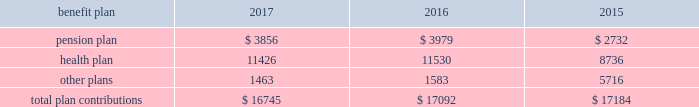112 / sl green realty corp .
2017 annual report 20 .
Commitments and contingencies legal proceedings as of december a031 , 2017 , the company and the operating partnership were not involved in any material litigation nor , to management 2019s knowledge , was any material litigation threat- ened against us or our portfolio which if adversely determined could have a material adverse impact on us .
Environmental matters our management believes that the properties are in compliance in all material respects with applicable federal , state and local ordinances and regulations regarding environmental issues .
Management is not aware of any environmental liability that it believes would have a materially adverse impact on our financial position , results of operations or cash flows .
Management is unaware of any instances in which it would incur significant envi- ronmental cost if any of our properties were sold .
Employment agreements we have entered into employment agreements with certain exec- utives , which expire between december a02018 and february a02020 .
The minimum cash-based compensation , including base sal- ary and guaranteed bonus payments , associated with these employment agreements total $ 5.4 a0million for 2018 .
In addition these employment agreements provide for deferred compen- sation awards based on our stock price and which were valued at $ 1.6 a0million on the grant date .
The value of these awards may change based on fluctuations in our stock price .
Insurance we maintain 201call-risk 201d property and rental value coverage ( includ- ing coverage regarding the perils of flood , earthquake and terrorism , excluding nuclear , biological , chemical , and radiological terrorism ( 201cnbcr 201d ) ) , within three property insurance programs and liability insurance .
Separate property and liability coverage may be purchased on a stand-alone basis for certain assets , such as the development of one vanderbilt .
Additionally , our captive insurance company , belmont insurance company , or belmont , pro- vides coverage for nbcr terrorist acts above a specified trigger , although if belmont is required to pay a claim under our insur- ance policies , we would ultimately record the loss to the extent of belmont 2019s required payment .
However , there is no assurance that in the future we will be able to procure coverage at a reasonable cost .
Further , if we experience losses that are uninsured or that exceed policy limits , we could lose the capital invested in the damaged properties as well as the anticipated future cash flows from those plan trustees adopted a rehabilitation plan consistent with this requirement .
No surcharges have been paid to the pension plan as of december a031 , 2017 .
For the pension plan years ended june a030 , 2017 , 2016 , and 2015 , the plan received contributions from employers totaling $ 257.8 a0million , $ 249.5 a0million , and $ 221.9 a0million .
Our contributions to the pension plan represent less than 5.0% ( 5.0 % ) of total contributions to the plan .
The health plan was established under the terms of collective bargaining agreements between the union , the realty advisory board on labor relations , inc .
And certain other employees .
The health plan provides health and other benefits to eligible participants employed in the building service industry who are covered under collective bargaining agreements , or other writ- ten agreements , with the union .
The health plan is administered by a board of trustees with equal representation by the employ- ers and the union and operates under employer identification number a013-2928869 .
The health plan receives contributions in accordance with collective bargaining agreements or participa- tion agreements .
Generally , these agreements provide that the employers contribute to the health plan at a fixed rate on behalf of each covered employee .
For the health plan years ended , june a030 , 2017 , 2016 , and 2015 , the plan received contributions from employers totaling $ 1.3 a0billion , $ 1.2 a0billion and $ 1.1 a0billion , respectively .
Our contributions to the health plan represent less than 5.0% ( 5.0 % ) of total contributions to the plan .
Contributions we made to the multi-employer plans for the years ended december a031 , 2017 , 2016 and 2015 are included in the table below ( in thousands ) : .
401 ( k ) plan in august a01997 , we implemented a 401 ( k ) a0savings/retirement plan , or the 401 ( k ) a0plan , to cover eligible employees of ours , and any designated affiliate .
The 401 ( k ) a0plan permits eligible employees to defer up to 15% ( 15 % ) of their annual compensation , subject to certain limitations imposed by the code .
The employees 2019 elective deferrals are immediately vested and non-forfeitable upon contribution to the 401 ( k ) a0plan .
During a02003 , we amended our 401 ( k ) a0plan to pro- vide for discretionary matching contributions only .
For 2017 , 2016 and 2015 , a matching contribution equal to 50% ( 50 % ) of the first 6% ( 6 % ) of annual compensation was made .
For the year ended december a031 , 2017 , we made a matching contribution of $ 728782 .
For the years ended december a031 , 2016 and 2015 , we made matching contribu- tions of $ 566000 and $ 550000 , respectively. .
What was the range of the amount , in millions , the plan received from employers for the pension plan in 2015 , 2016 and 2017? 
Computations: (257.8 - 221.9)
Answer: 35.9. 